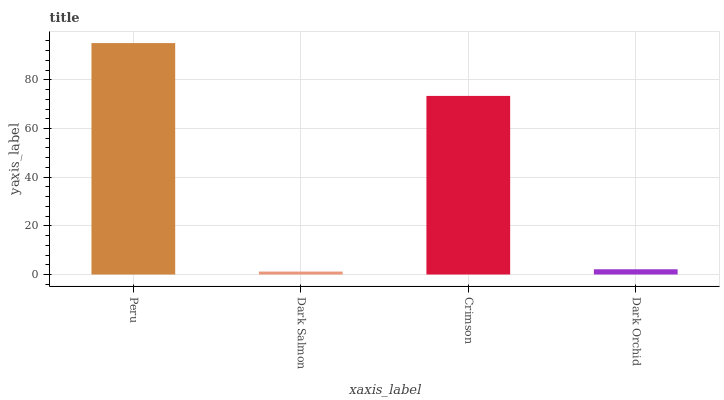Is Dark Salmon the minimum?
Answer yes or no. Yes. Is Peru the maximum?
Answer yes or no. Yes. Is Crimson the minimum?
Answer yes or no. No. Is Crimson the maximum?
Answer yes or no. No. Is Crimson greater than Dark Salmon?
Answer yes or no. Yes. Is Dark Salmon less than Crimson?
Answer yes or no. Yes. Is Dark Salmon greater than Crimson?
Answer yes or no. No. Is Crimson less than Dark Salmon?
Answer yes or no. No. Is Crimson the high median?
Answer yes or no. Yes. Is Dark Orchid the low median?
Answer yes or no. Yes. Is Dark Orchid the high median?
Answer yes or no. No. Is Dark Salmon the low median?
Answer yes or no. No. 